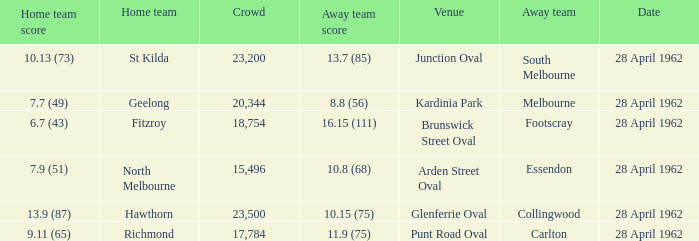What away team played at Brunswick Street Oval? Footscray. 